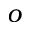<formula> <loc_0><loc_0><loc_500><loc_500>o</formula> 